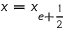Convert formula to latex. <formula><loc_0><loc_0><loc_500><loc_500>x = x _ { e + \frac { 1 } { 2 } }</formula> 